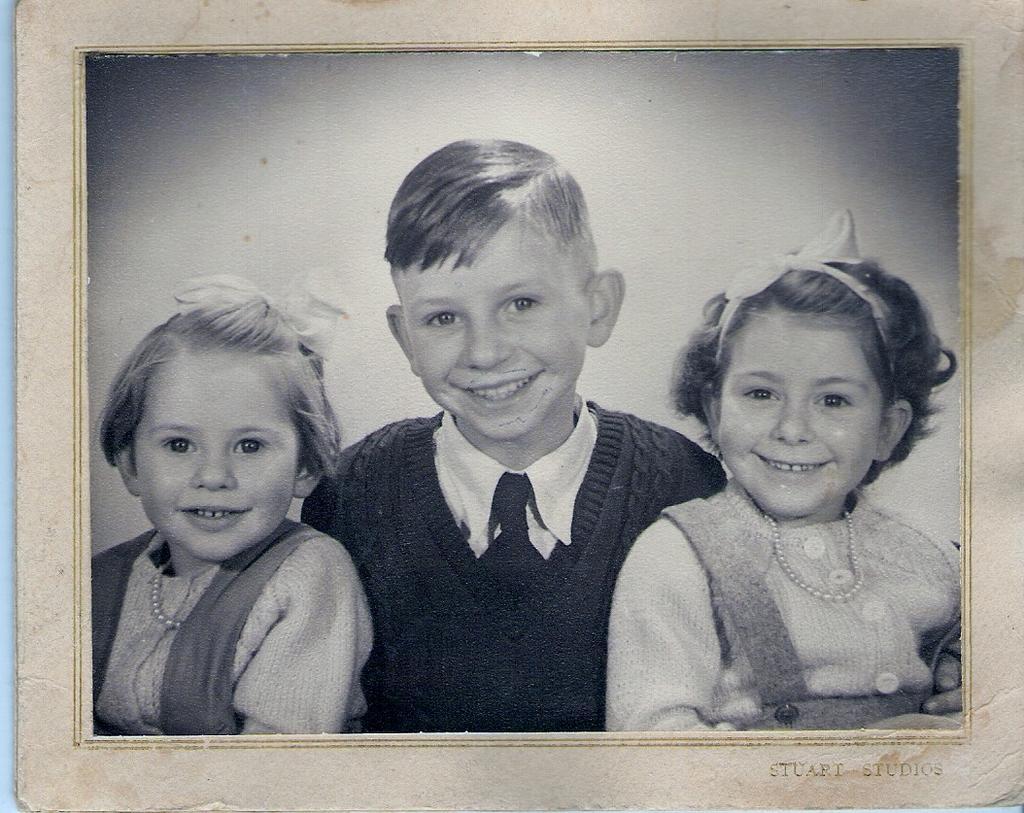Could you give a brief overview of what you see in this image? In this image we can see the photograph of the smiling girls and a boy. In the bottom right corner we can see the text. 